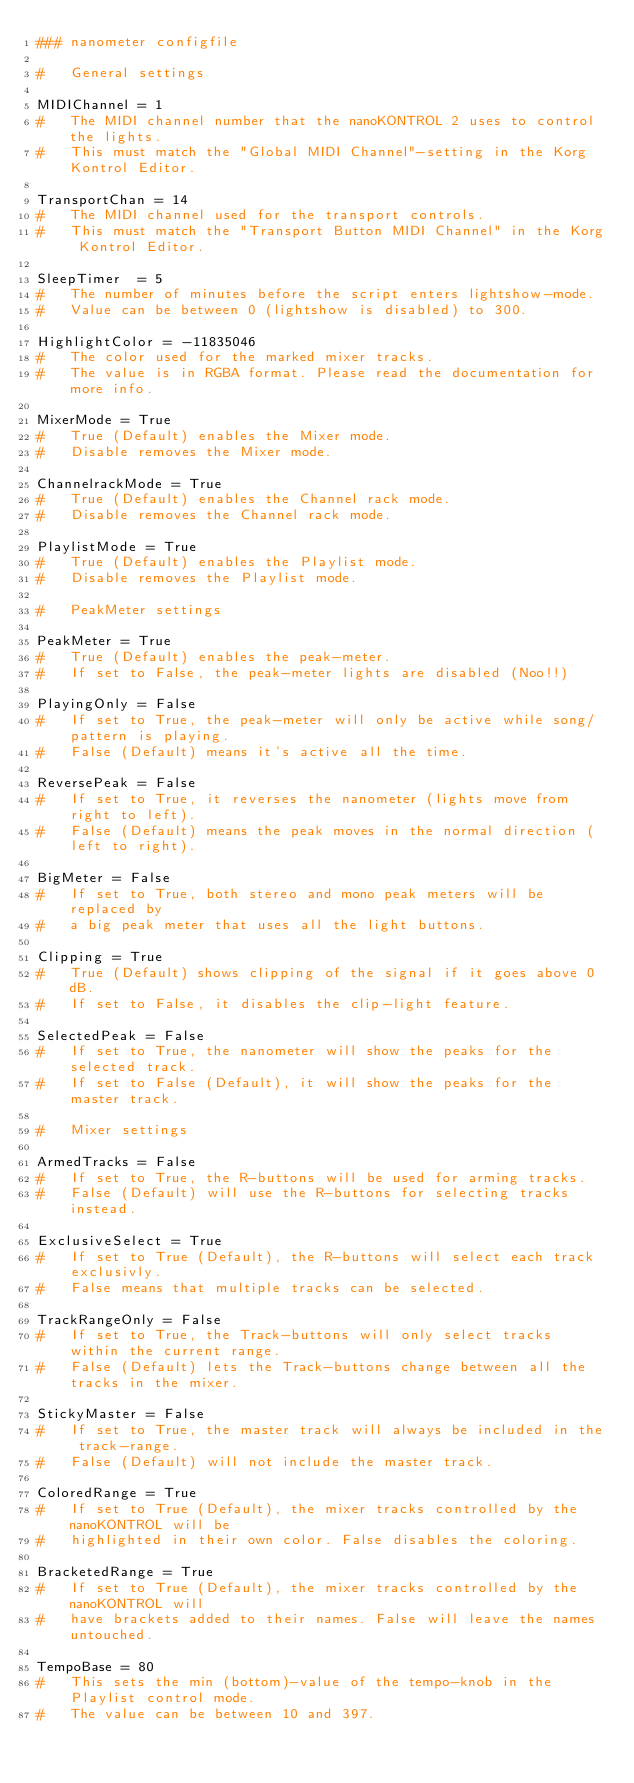Convert code to text. <code><loc_0><loc_0><loc_500><loc_500><_Python_>### nanometer configfile

#	General settings

MIDIChannel = 1
#	The MIDI channel number that the nanoKONTROL 2 uses to control the lights.
#	This must match the "Global MIDI Channel"-setting in the Korg Kontrol Editor.

TransportChan = 14
#	The MIDI channel used for the transport controls.
#	This must match the "Transport Button MIDI Channel" in the Korg Kontrol Editor.

SleepTimer  = 5
#	The number of minutes before the script enters lightshow-mode. 
#	Value can be between 0 (lightshow is disabled) to 300.

HighlightColor = -11835046
#	The color used for the marked mixer tracks.
#	The value is in RGBA format. Please read the documentation for more info.

MixerMode = True
#	True (Default) enables the Mixer mode.
#	Disable removes the Mixer mode.

ChannelrackMode = True
#	True (Default) enables the Channel rack mode.
#	Disable removes the Channel rack mode.

PlaylistMode = True
#	True (Default) enables the Playlist mode.
#	Disable removes the Playlist mode.

#	PeakMeter settings

PeakMeter = True
#	True (Default) enables the peak-meter.
#	If set to False, the peak-meter lights are disabled (Noo!!)

PlayingOnly = False
#	If set to True, the peak-meter will only be active while song/pattern is playing.
#	False (Default) means it's active all the time.

ReversePeak = False
#	If set to True, it reverses the nanometer (lights move from right to left).
#	False (Default) means the peak moves in the normal direction (left to right).

BigMeter = False
#	If set to True, both stereo and mono peak meters will be replaced by
#	a big peak meter that uses all the light buttons.

Clipping = True
#	True (Default) shows clipping of the signal if it goes above 0 dB.
#	If set to False, it disables the clip-light feature.

SelectedPeak = False
#	If set to True, the nanometer will show the peaks for the selected track.
#	If set to False (Default), it will show the peaks for the master track.

#	Mixer settings

ArmedTracks = False
#	If set to True, the R-buttons will be used for arming tracks.
#	False (Default) will use the R-buttons for selecting tracks instead.

ExclusiveSelect = True
#	If set to True (Default), the R-buttons will select each track exclusivly.
#	False means that multiple tracks can be selected.

TrackRangeOnly = False
#	If set to True, the Track-buttons will only select tracks within the current range.
#	False (Default) lets the Track-buttons change between all the tracks in the mixer.

StickyMaster = False
#	If set to True, the master track will always be included in the track-range.
#	False (Default) will not include the master track.

ColoredRange = True
#	If set to True (Default), the mixer tracks controlled by the nanoKONTROL will be
#	highlighted in their own color. False disables the coloring.

BracketedRange = True
#	If set to True (Default), the mixer tracks controlled by the nanoKONTROL will
#	have brackets added to their names. False will leave the names untouched.

TempoBase = 80
#	This sets the min (bottom)-value of the tempo-knob in the Playlist control mode.
#	The value can be between 10 and 397.

</code> 